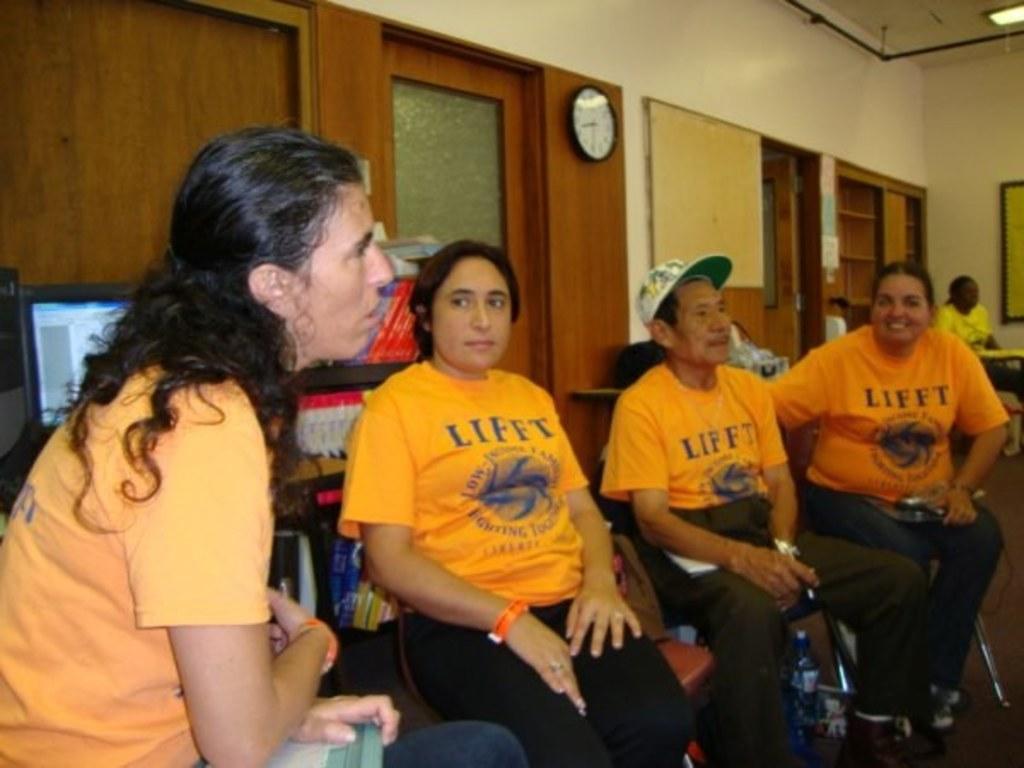Can you describe this image briefly? In this picture we can observe four members sitting in the chairs. All of them were wearing yellow color T shirts. On the left side there is a television. We can observe a white color wall clock here. There is a door which is in brown color. On the right side there are shelves. We can observe a wall here. 